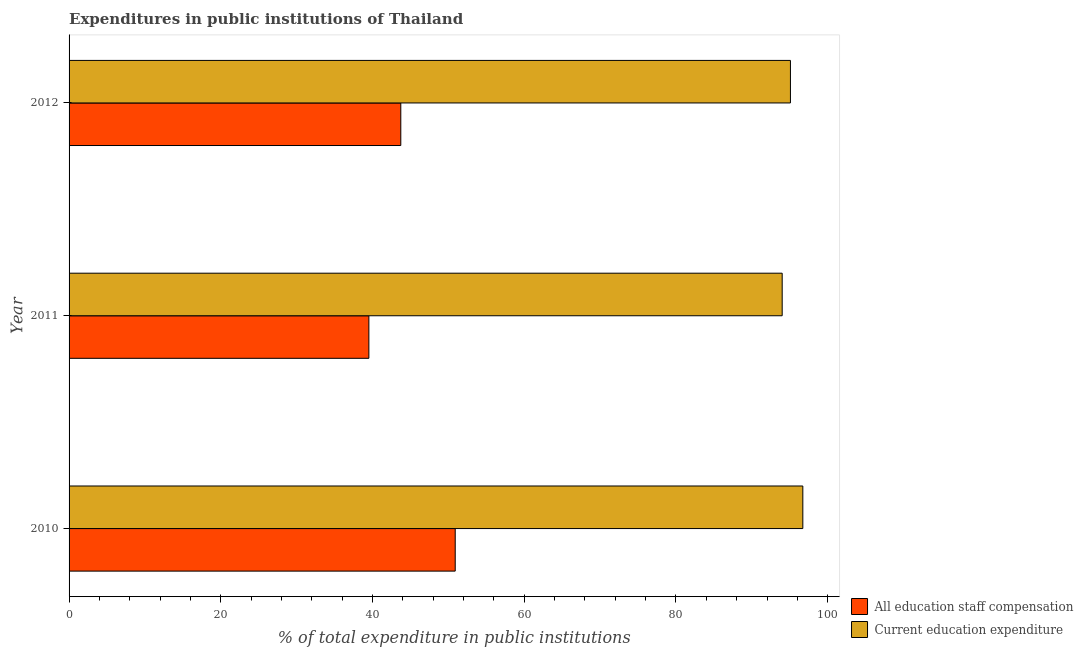How many groups of bars are there?
Offer a very short reply. 3. Are the number of bars per tick equal to the number of legend labels?
Keep it short and to the point. Yes. How many bars are there on the 1st tick from the top?
Make the answer very short. 2. How many bars are there on the 3rd tick from the bottom?
Ensure brevity in your answer.  2. What is the label of the 2nd group of bars from the top?
Provide a succinct answer. 2011. What is the expenditure in education in 2012?
Provide a short and direct response. 95.09. Across all years, what is the maximum expenditure in education?
Your answer should be compact. 96.72. Across all years, what is the minimum expenditure in staff compensation?
Provide a short and direct response. 39.52. In which year was the expenditure in education maximum?
Make the answer very short. 2010. In which year was the expenditure in education minimum?
Make the answer very short. 2011. What is the total expenditure in staff compensation in the graph?
Offer a very short reply. 134.15. What is the difference between the expenditure in education in 2010 and that in 2011?
Provide a succinct answer. 2.72. What is the difference between the expenditure in staff compensation in 2012 and the expenditure in education in 2010?
Give a very brief answer. -53. What is the average expenditure in education per year?
Offer a very short reply. 95.27. In the year 2012, what is the difference between the expenditure in staff compensation and expenditure in education?
Keep it short and to the point. -51.36. What is the ratio of the expenditure in staff compensation in 2010 to that in 2011?
Give a very brief answer. 1.29. Is the difference between the expenditure in education in 2010 and 2012 greater than the difference between the expenditure in staff compensation in 2010 and 2012?
Keep it short and to the point. No. What is the difference between the highest and the second highest expenditure in staff compensation?
Your response must be concise. 7.17. What is the difference between the highest and the lowest expenditure in education?
Provide a short and direct response. 2.72. Is the sum of the expenditure in education in 2011 and 2012 greater than the maximum expenditure in staff compensation across all years?
Offer a very short reply. Yes. What does the 2nd bar from the top in 2010 represents?
Offer a very short reply. All education staff compensation. What does the 2nd bar from the bottom in 2011 represents?
Offer a terse response. Current education expenditure. How many bars are there?
Make the answer very short. 6. How many years are there in the graph?
Keep it short and to the point. 3. Are the values on the major ticks of X-axis written in scientific E-notation?
Your answer should be very brief. No. Does the graph contain grids?
Keep it short and to the point. No. How many legend labels are there?
Provide a short and direct response. 2. What is the title of the graph?
Provide a succinct answer. Expenditures in public institutions of Thailand. What is the label or title of the X-axis?
Offer a terse response. % of total expenditure in public institutions. What is the label or title of the Y-axis?
Your answer should be very brief. Year. What is the % of total expenditure in public institutions in All education staff compensation in 2010?
Your response must be concise. 50.9. What is the % of total expenditure in public institutions of Current education expenditure in 2010?
Give a very brief answer. 96.72. What is the % of total expenditure in public institutions in All education staff compensation in 2011?
Give a very brief answer. 39.52. What is the % of total expenditure in public institutions of Current education expenditure in 2011?
Offer a very short reply. 94. What is the % of total expenditure in public institutions of All education staff compensation in 2012?
Provide a succinct answer. 43.73. What is the % of total expenditure in public institutions in Current education expenditure in 2012?
Your answer should be very brief. 95.09. Across all years, what is the maximum % of total expenditure in public institutions of All education staff compensation?
Provide a short and direct response. 50.9. Across all years, what is the maximum % of total expenditure in public institutions in Current education expenditure?
Your answer should be very brief. 96.72. Across all years, what is the minimum % of total expenditure in public institutions in All education staff compensation?
Offer a terse response. 39.52. Across all years, what is the minimum % of total expenditure in public institutions in Current education expenditure?
Offer a very short reply. 94. What is the total % of total expenditure in public institutions of All education staff compensation in the graph?
Make the answer very short. 134.15. What is the total % of total expenditure in public institutions in Current education expenditure in the graph?
Offer a terse response. 285.81. What is the difference between the % of total expenditure in public institutions of All education staff compensation in 2010 and that in 2011?
Ensure brevity in your answer.  11.38. What is the difference between the % of total expenditure in public institutions of Current education expenditure in 2010 and that in 2011?
Make the answer very short. 2.72. What is the difference between the % of total expenditure in public institutions in All education staff compensation in 2010 and that in 2012?
Your response must be concise. 7.17. What is the difference between the % of total expenditure in public institutions of Current education expenditure in 2010 and that in 2012?
Offer a very short reply. 1.63. What is the difference between the % of total expenditure in public institutions of All education staff compensation in 2011 and that in 2012?
Provide a succinct answer. -4.21. What is the difference between the % of total expenditure in public institutions of Current education expenditure in 2011 and that in 2012?
Give a very brief answer. -1.09. What is the difference between the % of total expenditure in public institutions of All education staff compensation in 2010 and the % of total expenditure in public institutions of Current education expenditure in 2011?
Make the answer very short. -43.1. What is the difference between the % of total expenditure in public institutions in All education staff compensation in 2010 and the % of total expenditure in public institutions in Current education expenditure in 2012?
Your answer should be compact. -44.19. What is the difference between the % of total expenditure in public institutions of All education staff compensation in 2011 and the % of total expenditure in public institutions of Current education expenditure in 2012?
Make the answer very short. -55.57. What is the average % of total expenditure in public institutions in All education staff compensation per year?
Offer a very short reply. 44.72. What is the average % of total expenditure in public institutions in Current education expenditure per year?
Make the answer very short. 95.27. In the year 2010, what is the difference between the % of total expenditure in public institutions in All education staff compensation and % of total expenditure in public institutions in Current education expenditure?
Provide a short and direct response. -45.82. In the year 2011, what is the difference between the % of total expenditure in public institutions in All education staff compensation and % of total expenditure in public institutions in Current education expenditure?
Provide a short and direct response. -54.48. In the year 2012, what is the difference between the % of total expenditure in public institutions in All education staff compensation and % of total expenditure in public institutions in Current education expenditure?
Your answer should be very brief. -51.36. What is the ratio of the % of total expenditure in public institutions of All education staff compensation in 2010 to that in 2011?
Offer a terse response. 1.29. What is the ratio of the % of total expenditure in public institutions in Current education expenditure in 2010 to that in 2011?
Offer a very short reply. 1.03. What is the ratio of the % of total expenditure in public institutions in All education staff compensation in 2010 to that in 2012?
Offer a very short reply. 1.16. What is the ratio of the % of total expenditure in public institutions in Current education expenditure in 2010 to that in 2012?
Keep it short and to the point. 1.02. What is the ratio of the % of total expenditure in public institutions in All education staff compensation in 2011 to that in 2012?
Your answer should be compact. 0.9. What is the ratio of the % of total expenditure in public institutions in Current education expenditure in 2011 to that in 2012?
Keep it short and to the point. 0.99. What is the difference between the highest and the second highest % of total expenditure in public institutions of All education staff compensation?
Offer a very short reply. 7.17. What is the difference between the highest and the second highest % of total expenditure in public institutions of Current education expenditure?
Your answer should be compact. 1.63. What is the difference between the highest and the lowest % of total expenditure in public institutions in All education staff compensation?
Offer a very short reply. 11.38. What is the difference between the highest and the lowest % of total expenditure in public institutions in Current education expenditure?
Your answer should be compact. 2.72. 